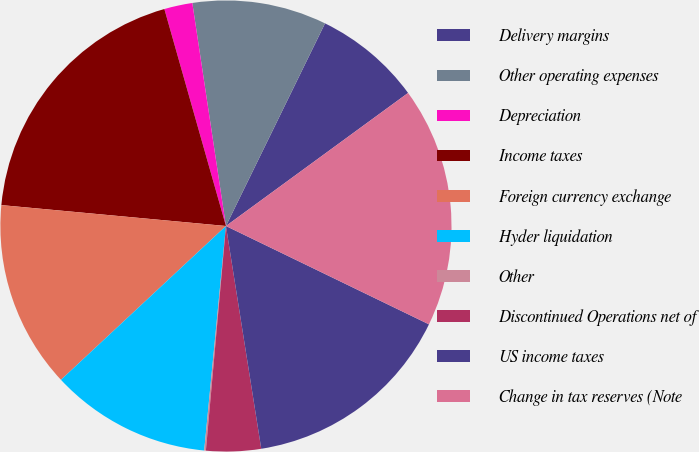<chart> <loc_0><loc_0><loc_500><loc_500><pie_chart><fcel>Delivery margins<fcel>Other operating expenses<fcel>Depreciation<fcel>Income taxes<fcel>Foreign currency exchange<fcel>Hyder liquidation<fcel>Other<fcel>Discontinued Operations net of<fcel>US income taxes<fcel>Change in tax reserves (Note<nl><fcel>7.72%<fcel>9.62%<fcel>2.02%<fcel>19.12%<fcel>13.42%<fcel>11.52%<fcel>0.12%<fcel>3.92%<fcel>15.32%<fcel>17.22%<nl></chart> 